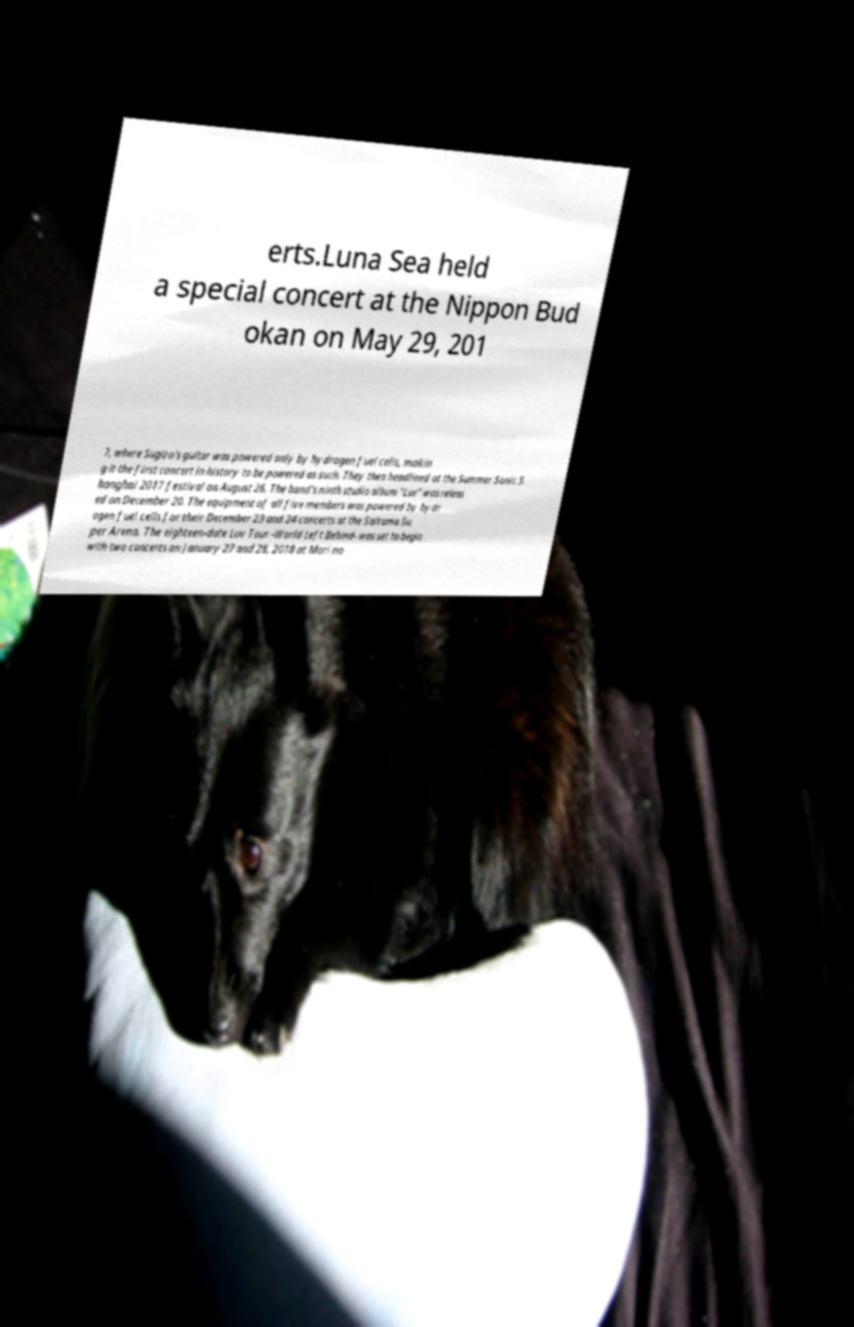I need the written content from this picture converted into text. Can you do that? erts.Luna Sea held a special concert at the Nippon Bud okan on May 29, 201 7, where Sugizo's guitar was powered only by hydrogen fuel cells, makin g it the first concert in history to be powered as such. They then headlined at the Summer Sonic S hanghai 2017 festival on August 26. The band's ninth studio album "Luv" was releas ed on December 20. The equipment of all five members was powered by hydr ogen fuel cells for their December 23 and 24 concerts at the Saitama Su per Arena. The eighteen-date Luv Tour -World Left Behind- was set to begin with two concerts on January 27 and 28, 2018 at Mori no 